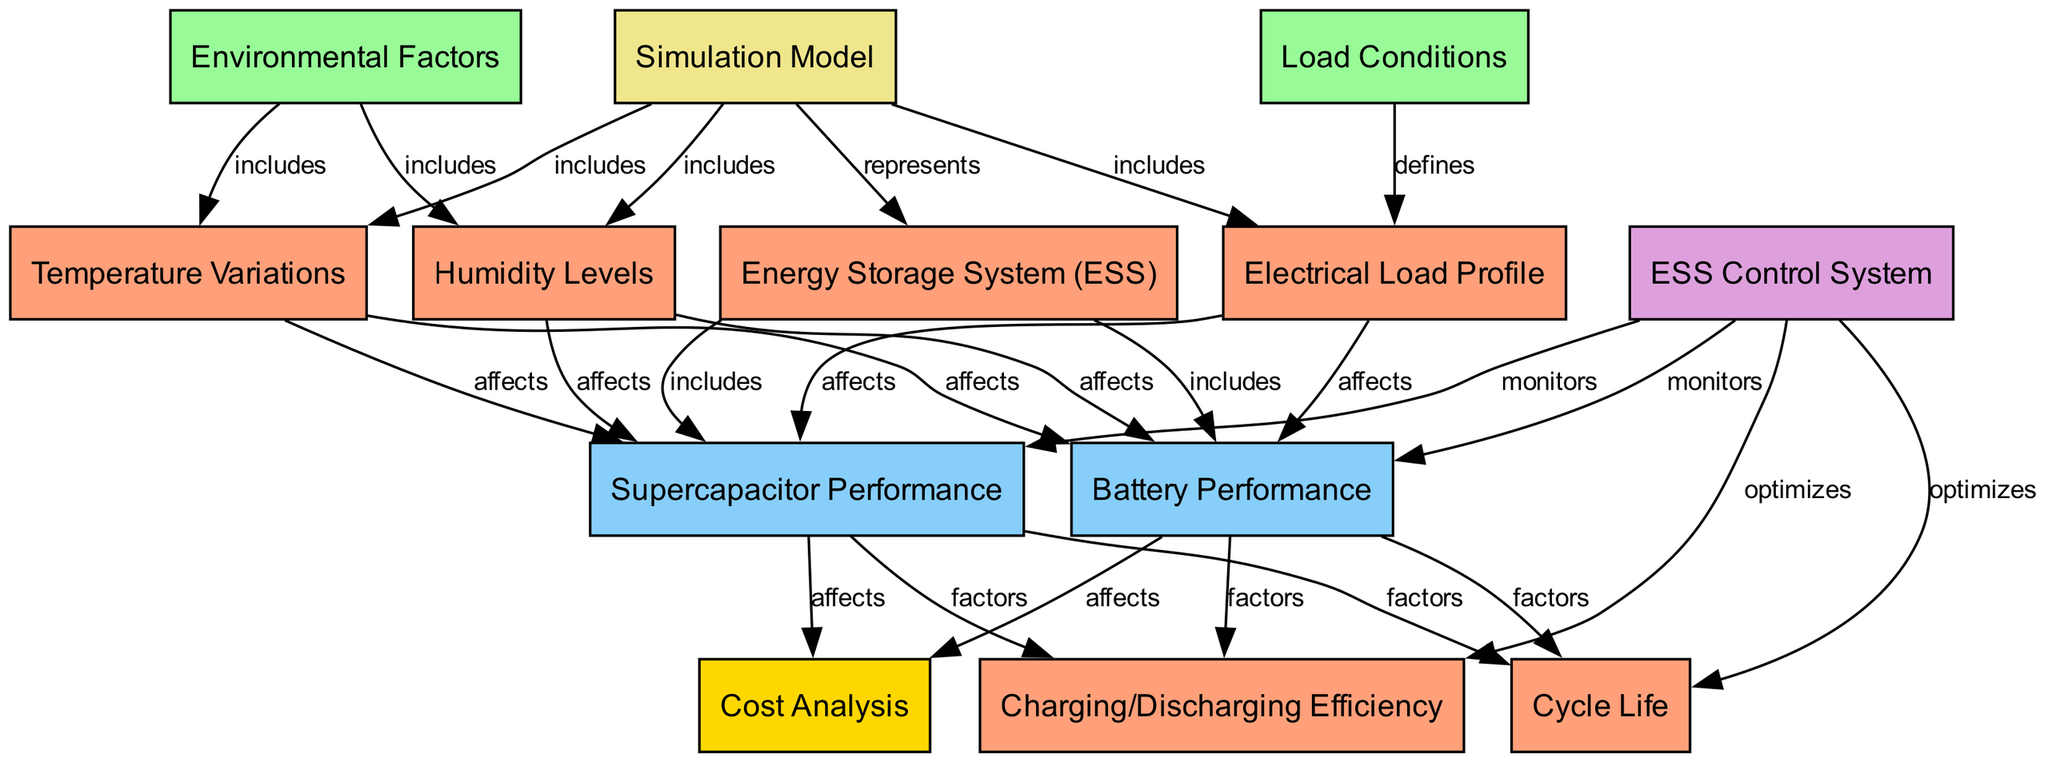What is the total number of nodes in the diagram? The diagram contains 13 nodes, which are the unique elements representing various components and relationships within the energy storage system.
Answer: 13 Which node represents the environmental factors? The node labeled "Environmental Factors" is represented by Node 3 in the diagram, which specifically encompasses temperature and humidity levels.
Answer: Environmental Factors How many edges are connected to the Energy Storage System (ESS) node? The ESS node is connected to six edges: four leading to performance nodes, one towards the control system, and one towards the simulation model.
Answer: 6 What is the relationship between Load Conditions and Electrical Load Profile? The relationship is defined by an edge labeled "defines," indicating that load conditions establish the specific electrical load profile.
Answer: defines Which node is monitored by the ESS Control System? The ESS Control System monitors both battery performance and supercapacitor performance. This is indicated by the edges leading from the control system to both performance nodes.
Answer: Battery Performance, Supercapacitor Performance How do Temperature Variations affect Battery Performance? Temperature Variations directly affect Battery Performance, as indicated by the edge labeled "affects" connecting the two nodes. This implies that as temperature fluctuates, it also influences the performance of the battery.
Answer: affects What factors affect Charging/Discharging Efficiency? Charging/Discharging Efficiency is influenced by both Battery Performance and Supercapacitor Performance, as indicated by the edges leading to these performance nodes, which are labeled "factors."
Answer: Battery Performance, Supercapacitor Performance Which node is involved in Cost Analysis? Cost Analysis is associated with both Battery Performance and Supercapacitor Performance, indicating that their efficiencies and lifecycle impacts the overall costs of the energy storage system.
Answer: Battery Performance, Supercapacitor Performance How does the Simulation Model relate to the Energy Storage System? The Simulation Model represents the Energy Storage System, indicating that the simulation showcases the performance and behavior of the system under various conditions and factors.
Answer: represents 